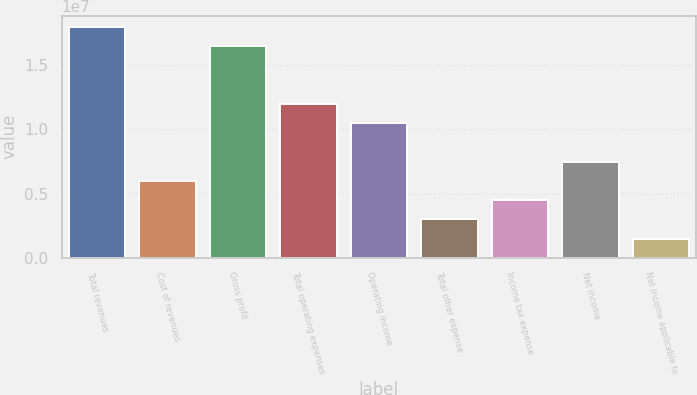Convert chart to OTSL. <chart><loc_0><loc_0><loc_500><loc_500><bar_chart><fcel>Total revenues<fcel>Cost of revenues<fcel>Gross profit<fcel>Total operating expenses<fcel>Operating income<fcel>Total other expense<fcel>Income tax expense<fcel>Net income<fcel>Net income applicable to<nl><fcel>1.79287e+07<fcel>5.97625e+06<fcel>1.64346e+07<fcel>1.19525e+07<fcel>1.04584e+07<fcel>2.98815e+06<fcel>4.4822e+06<fcel>7.4703e+06<fcel>1.4941e+06<nl></chart> 